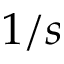<formula> <loc_0><loc_0><loc_500><loc_500>1 / s</formula> 